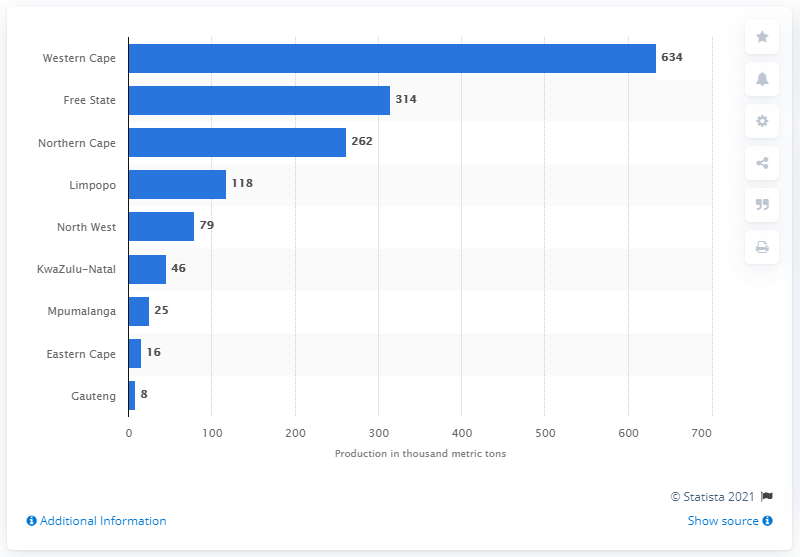Mention a couple of crucial points in this snapshot. Western Cape produced the highest volume of wheat in 2019 among all the states in India. 